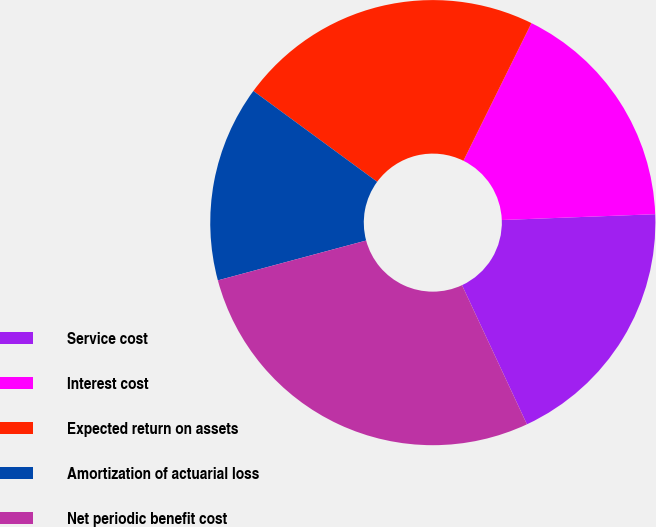Convert chart to OTSL. <chart><loc_0><loc_0><loc_500><loc_500><pie_chart><fcel>Service cost<fcel>Interest cost<fcel>Expected return on assets<fcel>Amortization of actuarial loss<fcel>Net periodic benefit cost<nl><fcel>18.65%<fcel>17.09%<fcel>22.23%<fcel>14.25%<fcel>27.77%<nl></chart> 